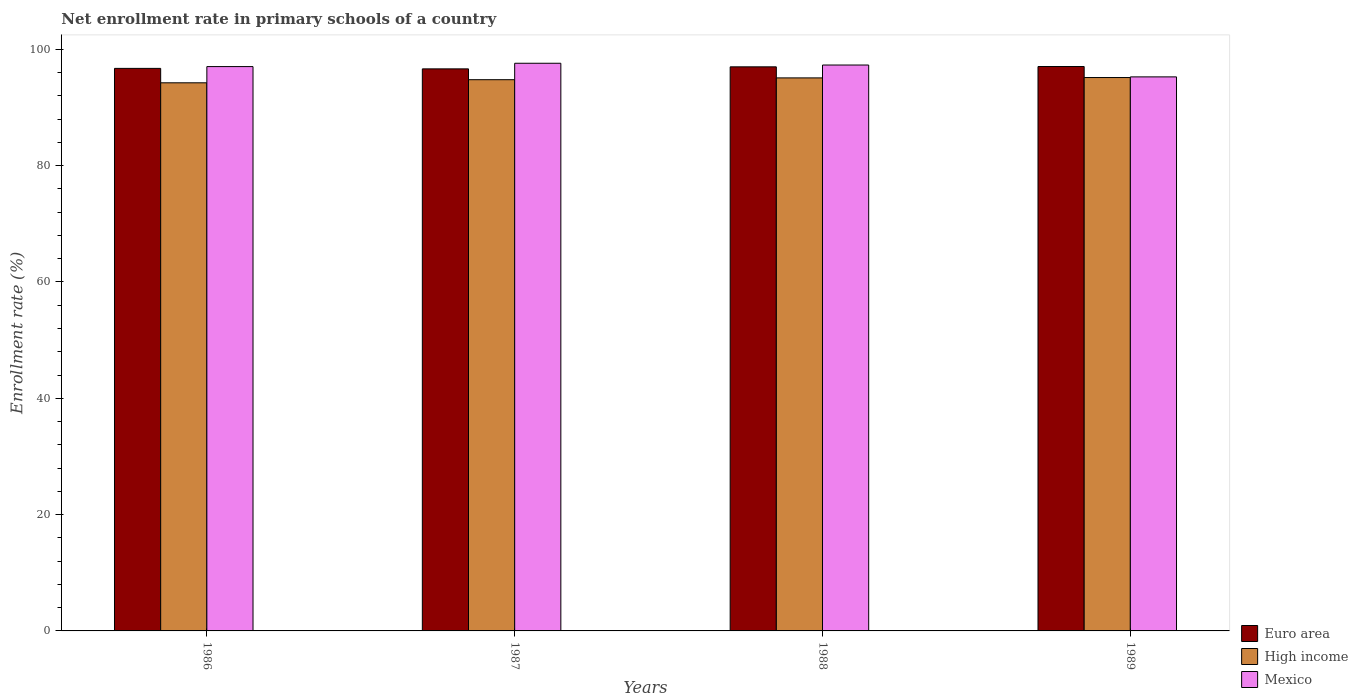How many different coloured bars are there?
Provide a short and direct response. 3. How many groups of bars are there?
Make the answer very short. 4. How many bars are there on the 2nd tick from the right?
Ensure brevity in your answer.  3. In how many cases, is the number of bars for a given year not equal to the number of legend labels?
Provide a short and direct response. 0. What is the enrollment rate in primary schools in Euro area in 1988?
Your response must be concise. 96.99. Across all years, what is the maximum enrollment rate in primary schools in High income?
Keep it short and to the point. 95.15. Across all years, what is the minimum enrollment rate in primary schools in Euro area?
Your answer should be very brief. 96.64. What is the total enrollment rate in primary schools in High income in the graph?
Your response must be concise. 379.27. What is the difference between the enrollment rate in primary schools in Mexico in 1986 and that in 1989?
Keep it short and to the point. 1.77. What is the difference between the enrollment rate in primary schools in Euro area in 1986 and the enrollment rate in primary schools in Mexico in 1987?
Provide a succinct answer. -0.88. What is the average enrollment rate in primary schools in High income per year?
Offer a very short reply. 94.82. In the year 1987, what is the difference between the enrollment rate in primary schools in Mexico and enrollment rate in primary schools in Euro area?
Offer a terse response. 0.97. In how many years, is the enrollment rate in primary schools in Mexico greater than 76 %?
Give a very brief answer. 4. What is the ratio of the enrollment rate in primary schools in High income in 1986 to that in 1987?
Your answer should be compact. 0.99. What is the difference between the highest and the second highest enrollment rate in primary schools in High income?
Your answer should be compact. 0.06. What is the difference between the highest and the lowest enrollment rate in primary schools in Mexico?
Give a very brief answer. 2.34. In how many years, is the enrollment rate in primary schools in Euro area greater than the average enrollment rate in primary schools in Euro area taken over all years?
Provide a short and direct response. 2. What does the 1st bar from the left in 1988 represents?
Offer a terse response. Euro area. What does the 3rd bar from the right in 1986 represents?
Your answer should be very brief. Euro area. Is it the case that in every year, the sum of the enrollment rate in primary schools in Mexico and enrollment rate in primary schools in High income is greater than the enrollment rate in primary schools in Euro area?
Ensure brevity in your answer.  Yes. Are all the bars in the graph horizontal?
Offer a very short reply. No. What is the difference between two consecutive major ticks on the Y-axis?
Offer a very short reply. 20. Does the graph contain any zero values?
Offer a terse response. No. Does the graph contain grids?
Ensure brevity in your answer.  No. Where does the legend appear in the graph?
Provide a succinct answer. Bottom right. How many legend labels are there?
Your answer should be very brief. 3. What is the title of the graph?
Ensure brevity in your answer.  Net enrollment rate in primary schools of a country. What is the label or title of the X-axis?
Your answer should be compact. Years. What is the label or title of the Y-axis?
Your response must be concise. Enrollment rate (%). What is the Enrollment rate (%) of Euro area in 1986?
Ensure brevity in your answer.  96.72. What is the Enrollment rate (%) of High income in 1986?
Offer a terse response. 94.25. What is the Enrollment rate (%) of Mexico in 1986?
Make the answer very short. 97.03. What is the Enrollment rate (%) in Euro area in 1987?
Keep it short and to the point. 96.64. What is the Enrollment rate (%) in High income in 1987?
Offer a terse response. 94.78. What is the Enrollment rate (%) in Mexico in 1987?
Offer a terse response. 97.61. What is the Enrollment rate (%) in Euro area in 1988?
Provide a short and direct response. 96.99. What is the Enrollment rate (%) in High income in 1988?
Provide a succinct answer. 95.09. What is the Enrollment rate (%) in Mexico in 1988?
Your answer should be compact. 97.3. What is the Enrollment rate (%) in Euro area in 1989?
Give a very brief answer. 97.04. What is the Enrollment rate (%) in High income in 1989?
Give a very brief answer. 95.15. What is the Enrollment rate (%) in Mexico in 1989?
Provide a succinct answer. 95.26. Across all years, what is the maximum Enrollment rate (%) in Euro area?
Offer a very short reply. 97.04. Across all years, what is the maximum Enrollment rate (%) in High income?
Your answer should be very brief. 95.15. Across all years, what is the maximum Enrollment rate (%) in Mexico?
Your answer should be very brief. 97.61. Across all years, what is the minimum Enrollment rate (%) in Euro area?
Make the answer very short. 96.64. Across all years, what is the minimum Enrollment rate (%) in High income?
Your response must be concise. 94.25. Across all years, what is the minimum Enrollment rate (%) of Mexico?
Your answer should be very brief. 95.26. What is the total Enrollment rate (%) in Euro area in the graph?
Make the answer very short. 387.4. What is the total Enrollment rate (%) in High income in the graph?
Your answer should be compact. 379.27. What is the total Enrollment rate (%) in Mexico in the graph?
Make the answer very short. 387.21. What is the difference between the Enrollment rate (%) of Euro area in 1986 and that in 1987?
Your answer should be compact. 0.08. What is the difference between the Enrollment rate (%) in High income in 1986 and that in 1987?
Your answer should be compact. -0.53. What is the difference between the Enrollment rate (%) in Mexico in 1986 and that in 1987?
Give a very brief answer. -0.57. What is the difference between the Enrollment rate (%) in Euro area in 1986 and that in 1988?
Keep it short and to the point. -0.27. What is the difference between the Enrollment rate (%) in High income in 1986 and that in 1988?
Your answer should be compact. -0.84. What is the difference between the Enrollment rate (%) in Mexico in 1986 and that in 1988?
Your answer should be very brief. -0.27. What is the difference between the Enrollment rate (%) of Euro area in 1986 and that in 1989?
Keep it short and to the point. -0.32. What is the difference between the Enrollment rate (%) in High income in 1986 and that in 1989?
Your answer should be very brief. -0.91. What is the difference between the Enrollment rate (%) of Mexico in 1986 and that in 1989?
Give a very brief answer. 1.77. What is the difference between the Enrollment rate (%) of Euro area in 1987 and that in 1988?
Offer a very short reply. -0.35. What is the difference between the Enrollment rate (%) in High income in 1987 and that in 1988?
Give a very brief answer. -0.31. What is the difference between the Enrollment rate (%) of Mexico in 1987 and that in 1988?
Offer a very short reply. 0.3. What is the difference between the Enrollment rate (%) of Euro area in 1987 and that in 1989?
Provide a short and direct response. -0.4. What is the difference between the Enrollment rate (%) in High income in 1987 and that in 1989?
Give a very brief answer. -0.37. What is the difference between the Enrollment rate (%) in Mexico in 1987 and that in 1989?
Your answer should be compact. 2.34. What is the difference between the Enrollment rate (%) in Euro area in 1988 and that in 1989?
Offer a terse response. -0.05. What is the difference between the Enrollment rate (%) of High income in 1988 and that in 1989?
Provide a succinct answer. -0.06. What is the difference between the Enrollment rate (%) in Mexico in 1988 and that in 1989?
Keep it short and to the point. 2.04. What is the difference between the Enrollment rate (%) of Euro area in 1986 and the Enrollment rate (%) of High income in 1987?
Offer a very short reply. 1.94. What is the difference between the Enrollment rate (%) in Euro area in 1986 and the Enrollment rate (%) in Mexico in 1987?
Make the answer very short. -0.88. What is the difference between the Enrollment rate (%) in High income in 1986 and the Enrollment rate (%) in Mexico in 1987?
Offer a terse response. -3.36. What is the difference between the Enrollment rate (%) of Euro area in 1986 and the Enrollment rate (%) of High income in 1988?
Provide a succinct answer. 1.63. What is the difference between the Enrollment rate (%) in Euro area in 1986 and the Enrollment rate (%) in Mexico in 1988?
Provide a succinct answer. -0.58. What is the difference between the Enrollment rate (%) of High income in 1986 and the Enrollment rate (%) of Mexico in 1988?
Your response must be concise. -3.06. What is the difference between the Enrollment rate (%) of Euro area in 1986 and the Enrollment rate (%) of High income in 1989?
Your response must be concise. 1.57. What is the difference between the Enrollment rate (%) in Euro area in 1986 and the Enrollment rate (%) in Mexico in 1989?
Your response must be concise. 1.46. What is the difference between the Enrollment rate (%) in High income in 1986 and the Enrollment rate (%) in Mexico in 1989?
Your response must be concise. -1.02. What is the difference between the Enrollment rate (%) of Euro area in 1987 and the Enrollment rate (%) of High income in 1988?
Your answer should be very brief. 1.55. What is the difference between the Enrollment rate (%) in Euro area in 1987 and the Enrollment rate (%) in Mexico in 1988?
Keep it short and to the point. -0.66. What is the difference between the Enrollment rate (%) of High income in 1987 and the Enrollment rate (%) of Mexico in 1988?
Keep it short and to the point. -2.52. What is the difference between the Enrollment rate (%) in Euro area in 1987 and the Enrollment rate (%) in High income in 1989?
Your answer should be compact. 1.49. What is the difference between the Enrollment rate (%) of Euro area in 1987 and the Enrollment rate (%) of Mexico in 1989?
Provide a succinct answer. 1.38. What is the difference between the Enrollment rate (%) in High income in 1987 and the Enrollment rate (%) in Mexico in 1989?
Your answer should be very brief. -0.48. What is the difference between the Enrollment rate (%) of Euro area in 1988 and the Enrollment rate (%) of High income in 1989?
Offer a very short reply. 1.84. What is the difference between the Enrollment rate (%) in Euro area in 1988 and the Enrollment rate (%) in Mexico in 1989?
Ensure brevity in your answer.  1.73. What is the difference between the Enrollment rate (%) in High income in 1988 and the Enrollment rate (%) in Mexico in 1989?
Ensure brevity in your answer.  -0.17. What is the average Enrollment rate (%) in Euro area per year?
Offer a very short reply. 96.85. What is the average Enrollment rate (%) in High income per year?
Provide a succinct answer. 94.82. What is the average Enrollment rate (%) in Mexico per year?
Offer a very short reply. 96.8. In the year 1986, what is the difference between the Enrollment rate (%) of Euro area and Enrollment rate (%) of High income?
Offer a very short reply. 2.48. In the year 1986, what is the difference between the Enrollment rate (%) of Euro area and Enrollment rate (%) of Mexico?
Your answer should be compact. -0.31. In the year 1986, what is the difference between the Enrollment rate (%) in High income and Enrollment rate (%) in Mexico?
Provide a succinct answer. -2.79. In the year 1987, what is the difference between the Enrollment rate (%) of Euro area and Enrollment rate (%) of High income?
Keep it short and to the point. 1.86. In the year 1987, what is the difference between the Enrollment rate (%) of Euro area and Enrollment rate (%) of Mexico?
Your answer should be compact. -0.97. In the year 1987, what is the difference between the Enrollment rate (%) of High income and Enrollment rate (%) of Mexico?
Keep it short and to the point. -2.83. In the year 1988, what is the difference between the Enrollment rate (%) of Euro area and Enrollment rate (%) of High income?
Your answer should be very brief. 1.9. In the year 1988, what is the difference between the Enrollment rate (%) in Euro area and Enrollment rate (%) in Mexico?
Offer a terse response. -0.31. In the year 1988, what is the difference between the Enrollment rate (%) in High income and Enrollment rate (%) in Mexico?
Give a very brief answer. -2.21. In the year 1989, what is the difference between the Enrollment rate (%) in Euro area and Enrollment rate (%) in High income?
Your answer should be very brief. 1.89. In the year 1989, what is the difference between the Enrollment rate (%) in Euro area and Enrollment rate (%) in Mexico?
Offer a terse response. 1.78. In the year 1989, what is the difference between the Enrollment rate (%) of High income and Enrollment rate (%) of Mexico?
Provide a short and direct response. -0.11. What is the ratio of the Enrollment rate (%) of Euro area in 1986 to that in 1987?
Make the answer very short. 1. What is the ratio of the Enrollment rate (%) in Mexico in 1986 to that in 1987?
Provide a short and direct response. 0.99. What is the ratio of the Enrollment rate (%) of Euro area in 1986 to that in 1988?
Offer a terse response. 1. What is the ratio of the Enrollment rate (%) of High income in 1986 to that in 1988?
Your response must be concise. 0.99. What is the ratio of the Enrollment rate (%) in Mexico in 1986 to that in 1988?
Your response must be concise. 1. What is the ratio of the Enrollment rate (%) in Mexico in 1986 to that in 1989?
Your answer should be very brief. 1.02. What is the ratio of the Enrollment rate (%) of Mexico in 1987 to that in 1988?
Offer a terse response. 1. What is the ratio of the Enrollment rate (%) of Euro area in 1987 to that in 1989?
Offer a very short reply. 1. What is the ratio of the Enrollment rate (%) of High income in 1987 to that in 1989?
Provide a succinct answer. 1. What is the ratio of the Enrollment rate (%) in Mexico in 1987 to that in 1989?
Your answer should be very brief. 1.02. What is the ratio of the Enrollment rate (%) of Euro area in 1988 to that in 1989?
Your response must be concise. 1. What is the ratio of the Enrollment rate (%) of Mexico in 1988 to that in 1989?
Make the answer very short. 1.02. What is the difference between the highest and the second highest Enrollment rate (%) in Euro area?
Keep it short and to the point. 0.05. What is the difference between the highest and the second highest Enrollment rate (%) of High income?
Your answer should be very brief. 0.06. What is the difference between the highest and the second highest Enrollment rate (%) in Mexico?
Offer a very short reply. 0.3. What is the difference between the highest and the lowest Enrollment rate (%) in Euro area?
Give a very brief answer. 0.4. What is the difference between the highest and the lowest Enrollment rate (%) of High income?
Offer a terse response. 0.91. What is the difference between the highest and the lowest Enrollment rate (%) of Mexico?
Offer a very short reply. 2.34. 